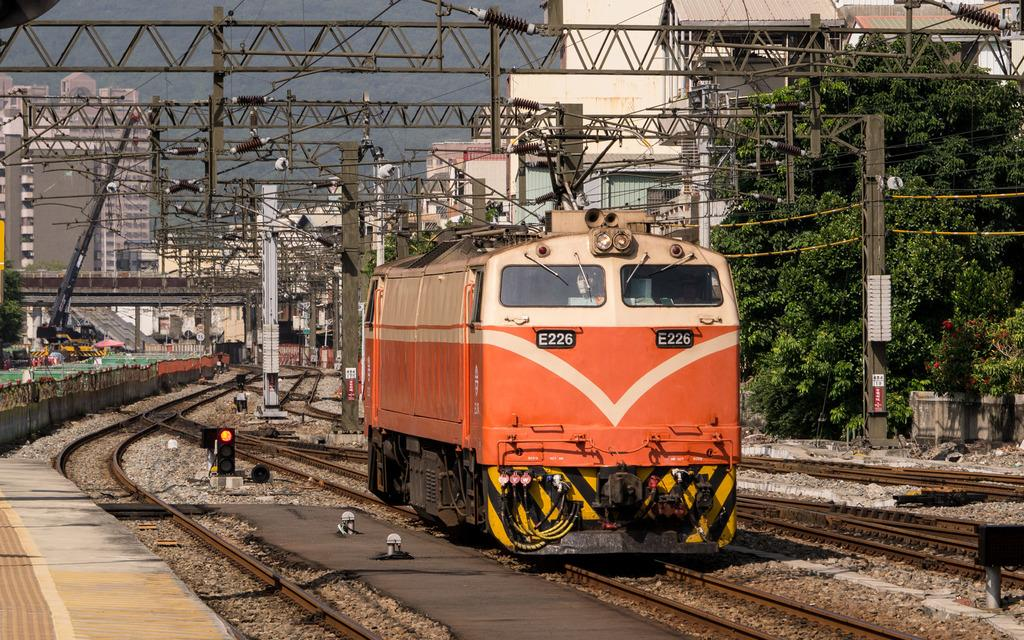Provide a one-sentence caption for the provided image. A single orange train cart on the tracks numbered E226. 